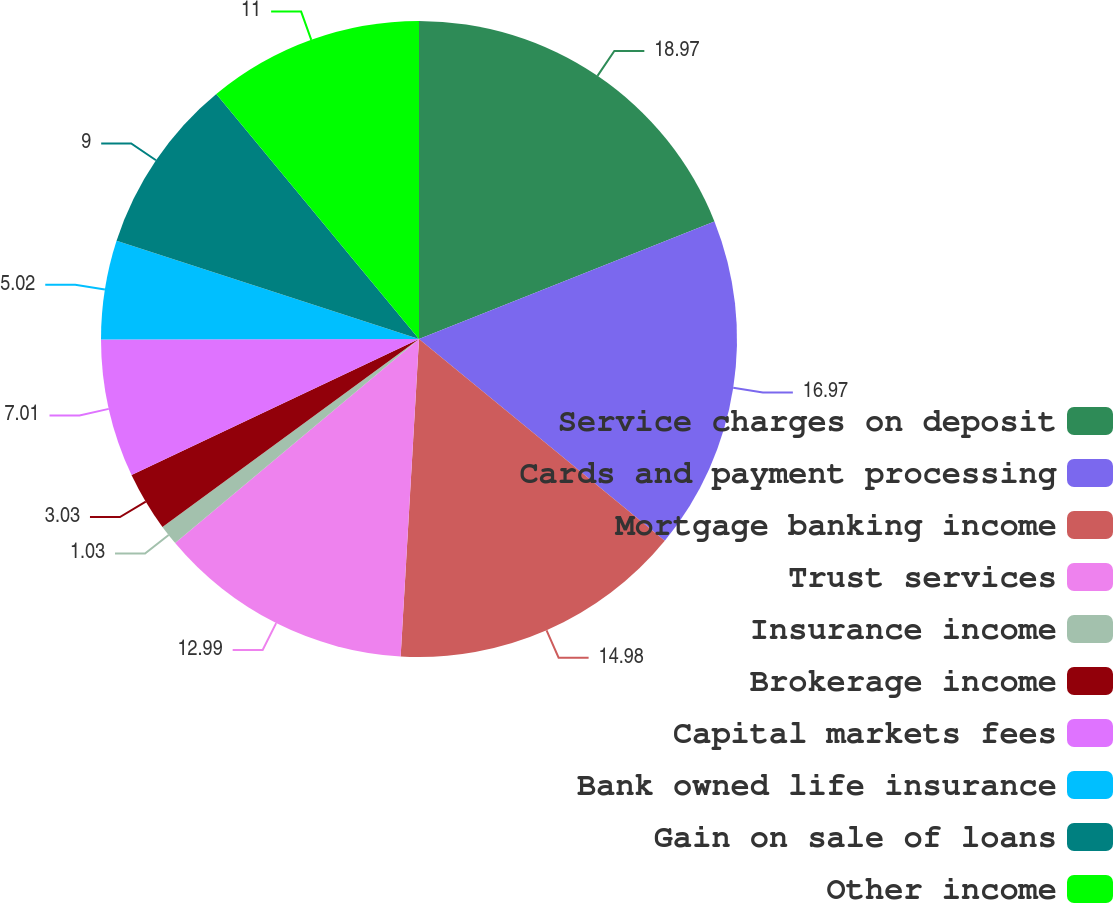<chart> <loc_0><loc_0><loc_500><loc_500><pie_chart><fcel>Service charges on deposit<fcel>Cards and payment processing<fcel>Mortgage banking income<fcel>Trust services<fcel>Insurance income<fcel>Brokerage income<fcel>Capital markets fees<fcel>Bank owned life insurance<fcel>Gain on sale of loans<fcel>Other income<nl><fcel>18.97%<fcel>16.97%<fcel>14.98%<fcel>12.99%<fcel>1.03%<fcel>3.03%<fcel>7.01%<fcel>5.02%<fcel>9.0%<fcel>11.0%<nl></chart> 